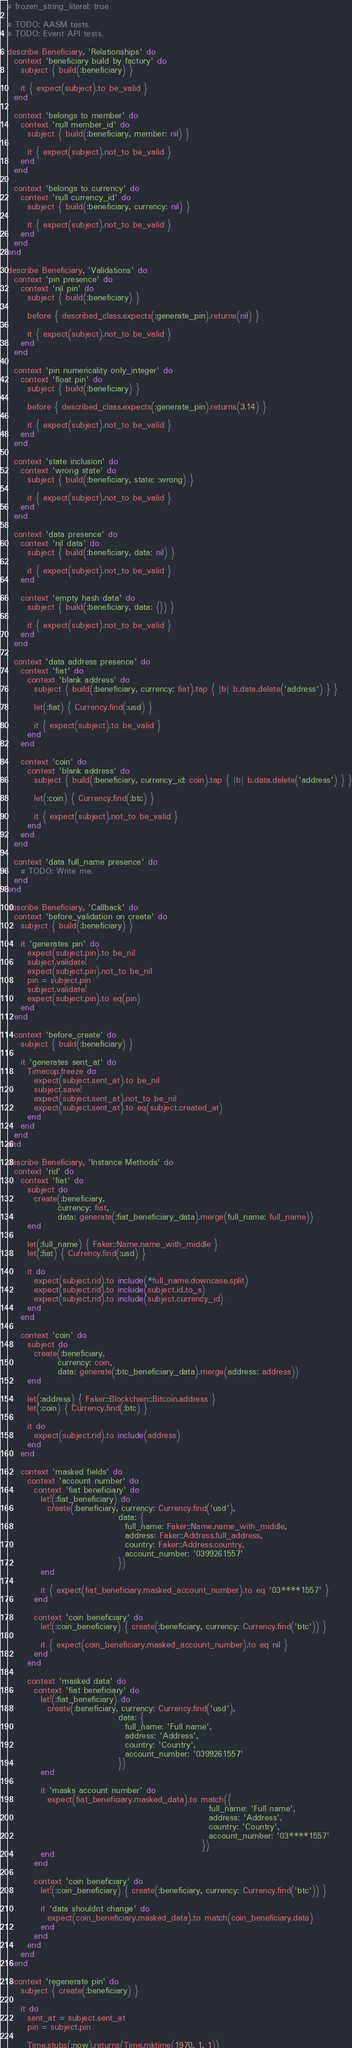<code> <loc_0><loc_0><loc_500><loc_500><_Ruby_># frozen_string_literal: true

# TODO: AASM tests.
# TODO: Event API tests.

describe Beneficiary, 'Relationships' do
  context 'beneficiary build by factory' do
    subject { build(:beneficiary) }

    it { expect(subject).to be_valid }
  end

  context 'belongs to member' do
    context 'null member_id' do
      subject { build(:beneficiary, member: nil) }

      it { expect(subject).not_to be_valid }
    end
  end

  context 'belongs to currency' do
    context 'null currency_id' do
      subject { build(:beneficiary, currency: nil) }

      it { expect(subject).not_to be_valid }
    end
  end
end

describe Beneficiary, 'Validations' do
  context 'pin presence' do
    context 'nil pin' do
      subject { build(:beneficiary) }

      before { described_class.expects(:generate_pin).returns(nil) }

      it { expect(subject).not_to be_valid }
    end
  end

  context 'pin numericality only_integer' do
    context 'float pin' do
      subject { build(:beneficiary) }

      before { described_class.expects(:generate_pin).returns(3.14) }

      it { expect(subject).not_to be_valid }
    end
  end

  context 'state inclusion' do
    context 'wrong state' do
      subject { build(:beneficiary, state: :wrong) }

      it { expect(subject).not_to be_valid }
    end
  end

  context 'data presence' do
    context 'nil data' do
      subject { build(:beneficiary, data: nil) }

      it { expect(subject).not_to be_valid }
    end

    context 'empty hash data' do
      subject { build(:beneficiary, data: {}) }

      it { expect(subject).not_to be_valid }
    end
  end

  context 'data address presence' do
    context 'fiat' do
      context 'blank address' do
        subject { build(:beneficiary, currency: fiat).tap { |b| b.data.delete('address') } }

        let(:fiat) { Currency.find(:usd) }

        it { expect(subject).to be_valid }
      end
    end

    context 'coin' do
      context 'blank address' do
        subject { build(:beneficiary, currency_id: coin).tap { |b| b.data.delete('address') } }

        let(:coin) { Currency.find(:btc) }

        it { expect(subject).not_to be_valid }
      end
    end
  end

  context 'data full_name presence' do
    # TODO: Write me.
  end
end

describe Beneficiary, 'Callback' do
  context 'before_validation on create' do
    subject { build(:beneficiary) }

    it 'generates pin' do
      expect(subject.pin).to be_nil
      subject.validate!
      expect(subject.pin).not_to be_nil
      pin = subject.pin
      subject.validate!
      expect(subject.pin).to eq(pin)
    end
  end

  context 'before_create' do
    subject { build(:beneficiary) }

    it 'generates sent_at' do
      Timecop.freeze do
        expect(subject.sent_at).to be_nil
        subject.save!
        expect(subject.sent_at).not_to be_nil
        expect(subject.sent_at).to eq(subject.created_at)
      end
    end
  end
end

describe Beneficiary, 'Instance Methods' do
  context 'rid' do
    context 'fiat' do
      subject do
        create(:beneficiary,
               currency: fiat,
               data: generate(:fiat_beneficiary_data).merge(full_name: full_name))
      end

      let(:full_name) { Faker::Name.name_with_middle }
      let(:fiat) { Currency.find(:usd) }

      it do
        expect(subject.rid).to include(*full_name.downcase.split)
        expect(subject.rid).to include(subject.id.to_s)
        expect(subject.rid).to include(subject.currency_id)
      end
    end

    context 'coin' do
      subject do
        create(:beneficiary,
               currency: coin,
               data: generate(:btc_beneficiary_data).merge(address: address))
      end

      let(:address) { Faker::Blockchain::Bitcoin.address }
      let(:coin) { Currency.find(:btc) }

      it do
        expect(subject.rid).to include(address)
      end
    end

    context 'masked fields' do
      context 'account number' do
        context 'fiat beneficiary' do
          let!(:fiat_beneficiary) do
            create(:beneficiary, currency: Currency.find('usd'),
                                 data: {
                                   full_name: Faker::Name.name_with_middle,
                                   address: Faker::Address.full_address,
                                   country: Faker::Address.country,
                                   account_number: '0399261557'
                                 })
          end

          it { expect(fiat_beneficiary.masked_account_number).to eq '03****1557' }
        end

        context 'coin beneficiary' do
          let!(:coin_beneficiary) { create(:beneficiary, currency: Currency.find('btc')) }

          it { expect(coin_beneficiary.masked_account_number).to eq nil }
        end
      end

      context 'masked data' do
        context 'fiat beneficiary' do
          let!(:fiat_beneficiary) do
            create(:beneficiary, currency: Currency.find('usd'),
                                 data: {
                                   full_name: 'Full name',
                                   address: 'Address',
                                   country: 'Country',
                                   account_number: '0399261557'
                                 })
          end

          it 'masks account number' do
            expect(fiat_beneficiary.masked_data).to match({
                                                            full_name: 'Full name',
                                                            address: 'Address',
                                                            country: 'Country',
                                                            account_number: '03****1557'
                                                          })
          end
        end

        context 'coin beneficiary' do
          let!(:coin_beneficiary) { create(:beneficiary, currency: Currency.find('btc')) }

          it 'data shouldnt change' do
            expect(coin_beneficiary.masked_data).to match(coin_beneficiary.data)
          end
        end
      end
    end
  end

  context 'regenerate pin' do
    subject { create(:beneficiary) }

    it do
      sent_at = subject.sent_at
      pin = subject.pin

      Time.stubs(:now).returns(Time.mktime(1970, 1, 1))</code> 